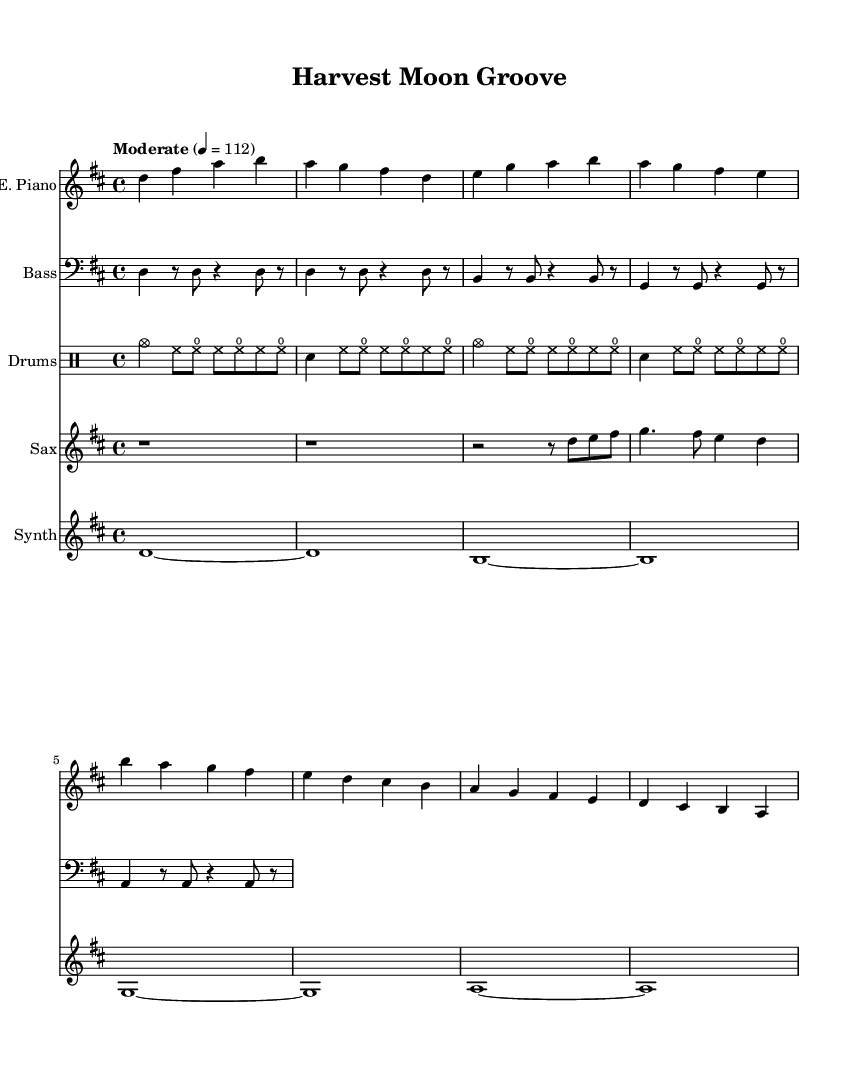What is the key signature of this music? The key signature is indicated by the presence of two sharps, which represent F# and C#. This means that the piece is in D major.
Answer: D major What is the time signature of the piece? The time signature, found at the beginning of the music, shows a 4 over 4, indicating that there are four beats in each measure and a quarter note receives one beat.
Answer: 4/4 What is the tempo marking for this piece? The tempo marking is specified with the word "Moderate" and a metronome marking of 112, meaning that the piece should be played at a moderate speed of 112 beats per minute.
Answer: Moderate 4 = 112 How many measures does the electric piano section contain? Counting the bars in the electric piano part shows there are eight measures total, comprised of several phrases. Each measure is defined by vertical lines.
Answer: Eight measures What instruments are featured in this score? The score includes five distinct instruments: electric piano, bass, drums, saxophone, and synthesizer, indicated by the respective instrument headers.
Answer: Electric piano, bass, drums, saxophone, synthesizer Which instrument plays the longest sustained note? The synthesizer plays the longest sustained notes, represented by the tied whole notes, demonstrating a longer duration than the other instruments.
Answer: Synthesizer How does the drum kit contribute to the overall jazz feel? The drum kit employs various techniques, such as using cymbals and snare hits, creating a swing feel characteristic of jazz. This contributes to the rhythmic foundation and atmosphere of the piece.
Answer: Swing feel 